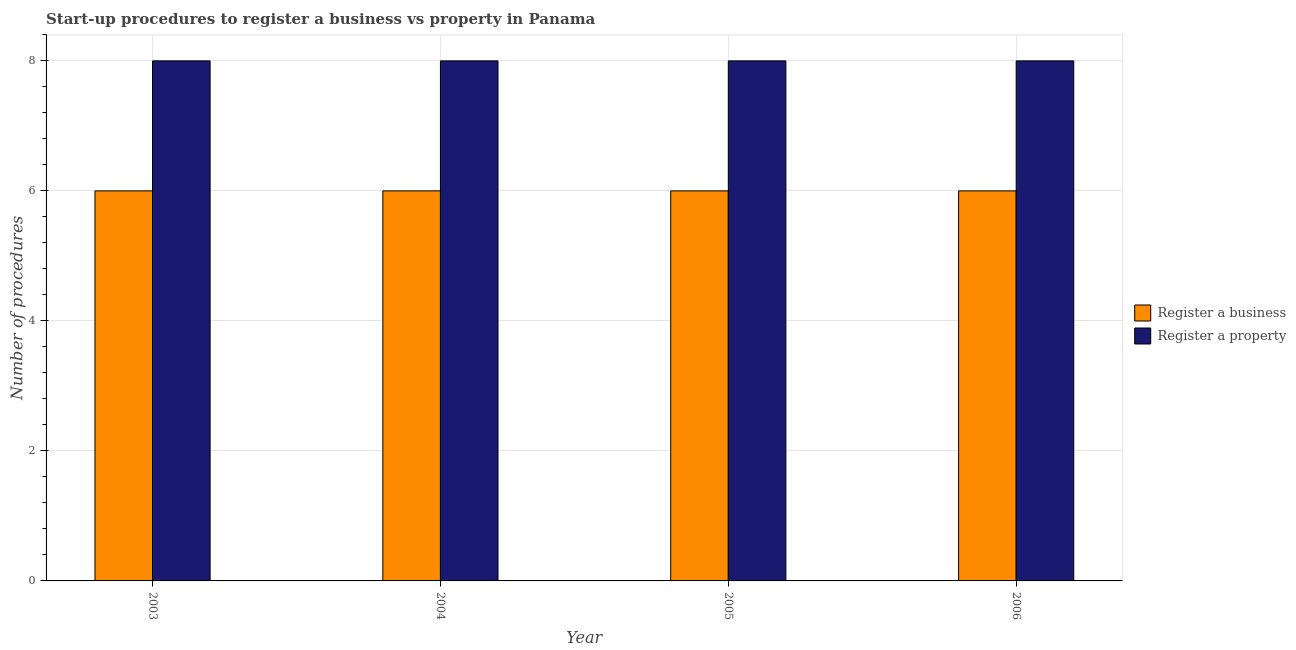Are the number of bars per tick equal to the number of legend labels?
Offer a very short reply. Yes. How many bars are there on the 1st tick from the left?
Keep it short and to the point. 2. How many bars are there on the 1st tick from the right?
Provide a succinct answer. 2. What is the number of procedures to register a business in 2003?
Your answer should be very brief. 6. Across all years, what is the maximum number of procedures to register a property?
Give a very brief answer. 8. Across all years, what is the minimum number of procedures to register a property?
Keep it short and to the point. 8. In which year was the number of procedures to register a property maximum?
Your answer should be very brief. 2003. In which year was the number of procedures to register a property minimum?
Your answer should be very brief. 2003. What is the total number of procedures to register a property in the graph?
Provide a short and direct response. 32. What is the difference between the number of procedures to register a property in 2005 and the number of procedures to register a business in 2004?
Your answer should be very brief. 0. What is the average number of procedures to register a business per year?
Make the answer very short. 6. In how many years, is the number of procedures to register a business greater than 6.4?
Your answer should be very brief. 0. Is the number of procedures to register a business in 2003 less than that in 2004?
Provide a succinct answer. No. Is the difference between the number of procedures to register a business in 2003 and 2004 greater than the difference between the number of procedures to register a property in 2003 and 2004?
Offer a very short reply. No. What does the 2nd bar from the left in 2004 represents?
Your answer should be compact. Register a property. What does the 2nd bar from the right in 2003 represents?
Offer a very short reply. Register a business. Are all the bars in the graph horizontal?
Keep it short and to the point. No. Does the graph contain any zero values?
Your answer should be compact. No. How are the legend labels stacked?
Provide a short and direct response. Vertical. What is the title of the graph?
Provide a short and direct response. Start-up procedures to register a business vs property in Panama. What is the label or title of the X-axis?
Your response must be concise. Year. What is the label or title of the Y-axis?
Your response must be concise. Number of procedures. What is the Number of procedures of Register a business in 2003?
Offer a very short reply. 6. What is the Number of procedures of Register a property in 2003?
Offer a very short reply. 8. What is the Number of procedures of Register a business in 2004?
Provide a succinct answer. 6. What is the Number of procedures in Register a business in 2006?
Offer a terse response. 6. What is the Number of procedures of Register a property in 2006?
Ensure brevity in your answer.  8. Across all years, what is the maximum Number of procedures of Register a business?
Give a very brief answer. 6. Across all years, what is the maximum Number of procedures of Register a property?
Offer a terse response. 8. Across all years, what is the minimum Number of procedures of Register a business?
Your response must be concise. 6. Across all years, what is the minimum Number of procedures in Register a property?
Offer a terse response. 8. What is the total Number of procedures of Register a business in the graph?
Offer a terse response. 24. What is the difference between the Number of procedures in Register a business in 2003 and that in 2004?
Your answer should be very brief. 0. What is the difference between the Number of procedures of Register a business in 2003 and that in 2005?
Your answer should be very brief. 0. What is the difference between the Number of procedures in Register a property in 2003 and that in 2005?
Provide a short and direct response. 0. What is the difference between the Number of procedures in Register a property in 2003 and that in 2006?
Give a very brief answer. 0. What is the difference between the Number of procedures of Register a business in 2004 and that in 2005?
Keep it short and to the point. 0. What is the difference between the Number of procedures of Register a business in 2004 and that in 2006?
Ensure brevity in your answer.  0. What is the difference between the Number of procedures in Register a property in 2004 and that in 2006?
Your response must be concise. 0. What is the difference between the Number of procedures in Register a business in 2005 and that in 2006?
Make the answer very short. 0. What is the difference between the Number of procedures of Register a business in 2003 and the Number of procedures of Register a property in 2005?
Ensure brevity in your answer.  -2. What is the average Number of procedures of Register a business per year?
Your response must be concise. 6. What is the average Number of procedures in Register a property per year?
Offer a terse response. 8. In the year 2003, what is the difference between the Number of procedures of Register a business and Number of procedures of Register a property?
Your answer should be very brief. -2. In the year 2004, what is the difference between the Number of procedures of Register a business and Number of procedures of Register a property?
Provide a succinct answer. -2. In the year 2005, what is the difference between the Number of procedures of Register a business and Number of procedures of Register a property?
Offer a very short reply. -2. In the year 2006, what is the difference between the Number of procedures in Register a business and Number of procedures in Register a property?
Provide a short and direct response. -2. What is the ratio of the Number of procedures in Register a business in 2003 to that in 2005?
Your response must be concise. 1. What is the ratio of the Number of procedures of Register a property in 2003 to that in 2005?
Your answer should be very brief. 1. What is the ratio of the Number of procedures in Register a business in 2003 to that in 2006?
Give a very brief answer. 1. What is the ratio of the Number of procedures in Register a property in 2003 to that in 2006?
Provide a short and direct response. 1. What is the ratio of the Number of procedures in Register a business in 2004 to that in 2005?
Make the answer very short. 1. What is the ratio of the Number of procedures in Register a property in 2004 to that in 2005?
Make the answer very short. 1. What is the ratio of the Number of procedures in Register a business in 2005 to that in 2006?
Offer a very short reply. 1. What is the ratio of the Number of procedures in Register a property in 2005 to that in 2006?
Give a very brief answer. 1. What is the difference between the highest and the second highest Number of procedures of Register a business?
Give a very brief answer. 0. What is the difference between the highest and the second highest Number of procedures in Register a property?
Your answer should be very brief. 0. 